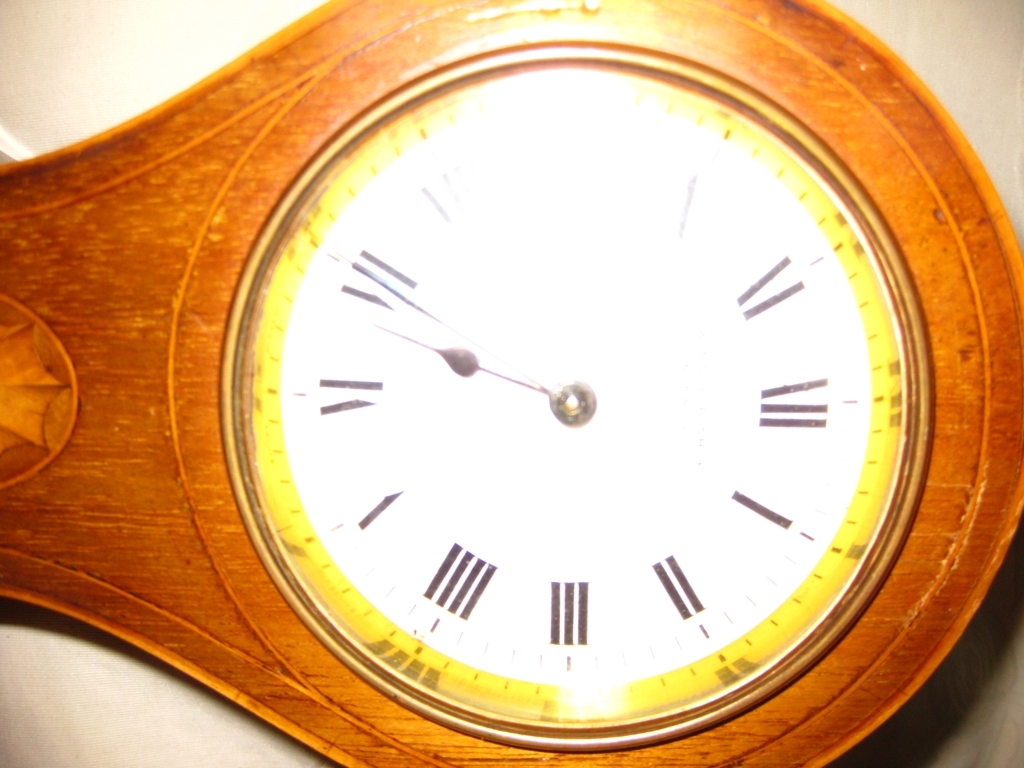What is the problem with the center part of this image?
A. Perfectly exposed
B. Slightly overexposed
C. Underexposed
Answer with the option's letter from the given choices directly.
 B. 